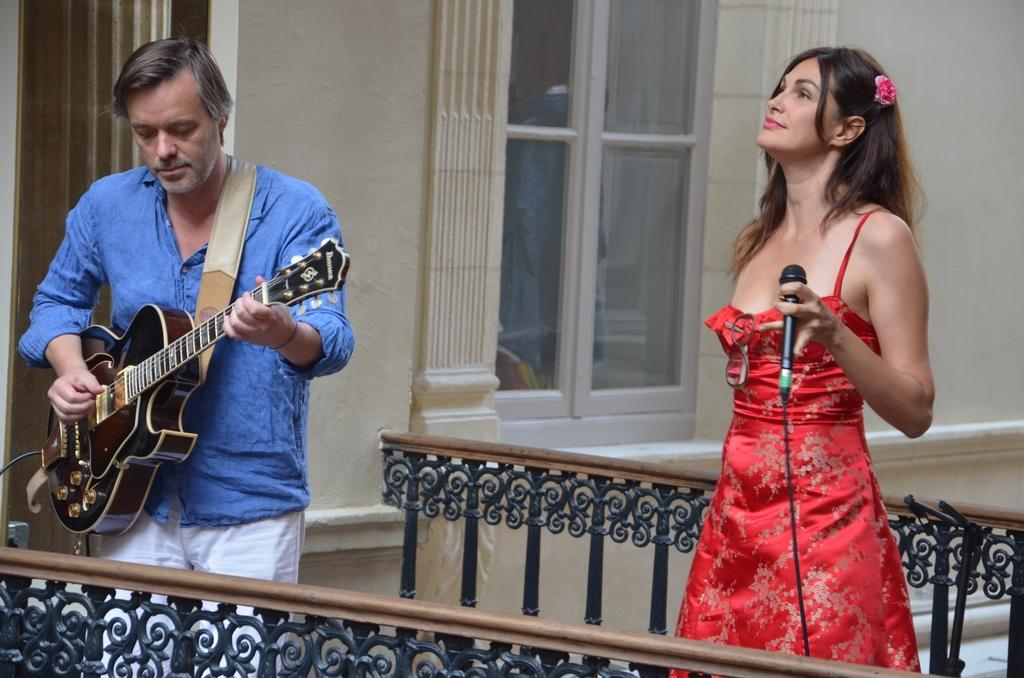Who is the main subject in the image? There is a person in the image. What is the person wearing? The person is wearing a blue shirt. What is the person doing in the image? The person is playing a guitar. Who else is present in the image? There is a woman in the image. What is the woman holding? The woman is holding a microphone. What type of spoon can be seen in the image? There is no spoon present in the image. What test is the person taking in the image? There is no test being taken in the image; the person is playing a guitar. 